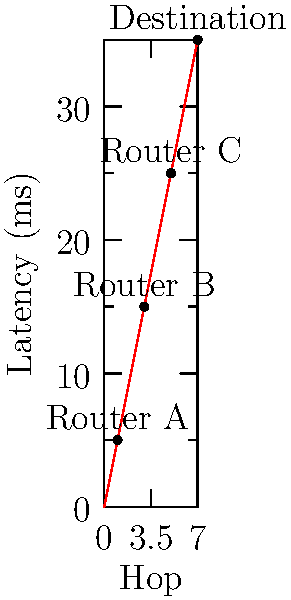Based on the traceroute output shown in the graph, which router is likely causing a significant delay in the network path? To determine which router is causing a significant delay, we need to analyze the latency increase between each hop:

1. Start at the origin (0,0), representing the source.
2. Router A (hop 1): Latency is 5ms. This is a normal initial hop.
3. Router B (hop 3): Latency is 15ms. The increase from A to B is 10ms (15ms - 5ms).
4. Router C (hop 5): Latency is 25ms. The increase from B to C is 10ms (25ms - 15ms).
5. Destination (hop 7): Latency is 35ms. The increase from C to the destination is 10ms (35ms - 25ms).

We observe that the latency increase between each router is consistent at 10ms, except for the initial hop to Router A. This suggests that there isn't a single router causing a significant delay in the path.

However, if we had to identify a potential bottleneck, it would be the link between the source and Router A, as it introduces the initial 5ms latency. This could be due to local network conditions or the first hop to the ISP.

In a typical network troubleshooting scenario, we would look for sudden large increases in latency between hops. Since we don't see that here, the network path appears to be functioning normally with consistent latency increases between routers.
Answer: No significant delay; consistent latency increases 